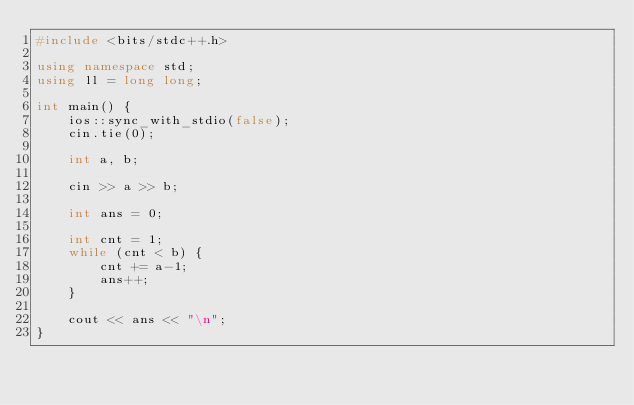<code> <loc_0><loc_0><loc_500><loc_500><_C++_>#include <bits/stdc++.h>

using namespace std;
using ll = long long;

int main() {
    ios::sync_with_stdio(false);
    cin.tie(0);

    int a, b;

    cin >> a >> b;

    int ans = 0;

    int cnt = 1;
    while (cnt < b) {
        cnt += a-1;
        ans++;
    }
    
    cout << ans << "\n";
}
</code> 